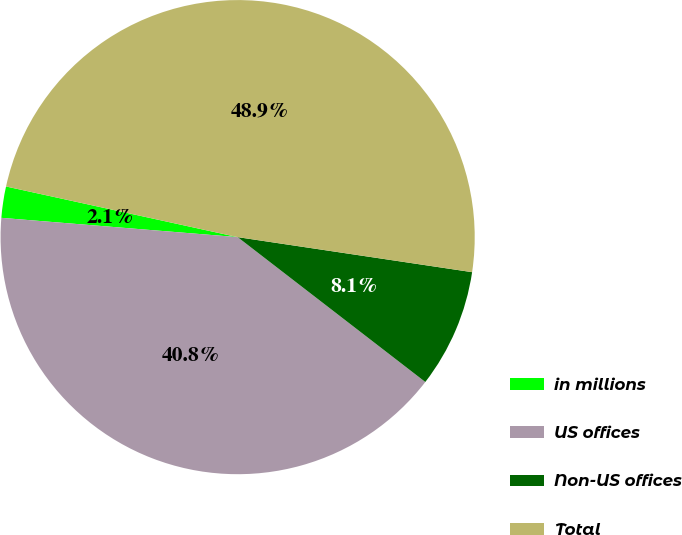Convert chart to OTSL. <chart><loc_0><loc_0><loc_500><loc_500><pie_chart><fcel>in millions<fcel>US offices<fcel>Non-US offices<fcel>Total<nl><fcel>2.13%<fcel>40.83%<fcel>8.1%<fcel>48.93%<nl></chart> 